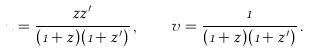<formula> <loc_0><loc_0><loc_500><loc_500>u = \frac { z z ^ { \prime } } { ( 1 + z ) ( 1 + z ^ { \prime } ) } \, , \quad v = \frac { 1 } { ( 1 + z ) ( 1 + z ^ { \prime } ) } \, .</formula> 